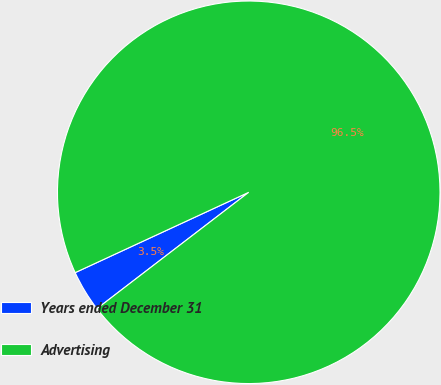<chart> <loc_0><loc_0><loc_500><loc_500><pie_chart><fcel>Years ended December 31<fcel>Advertising<nl><fcel>3.51%<fcel>96.49%<nl></chart> 